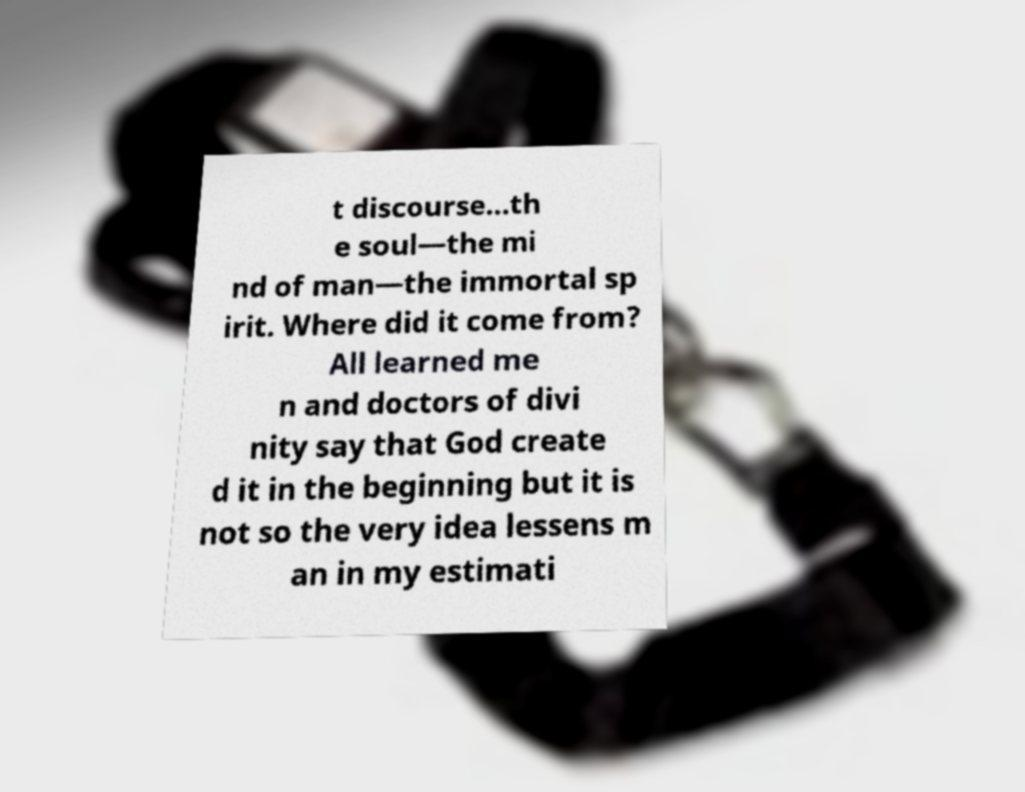Can you accurately transcribe the text from the provided image for me? t discourse...th e soul—the mi nd of man—the immortal sp irit. Where did it come from? All learned me n and doctors of divi nity say that God create d it in the beginning but it is not so the very idea lessens m an in my estimati 